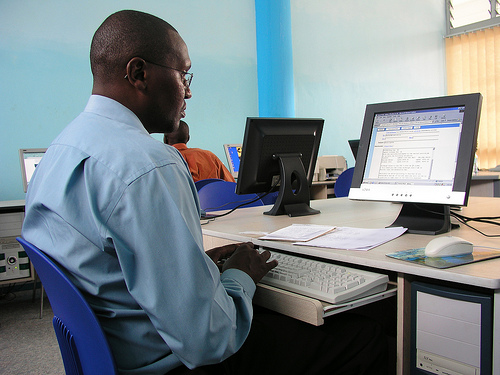<image>
Is the man on the keyboard? No. The man is not positioned on the keyboard. They may be near each other, but the man is not supported by or resting on top of the keyboard. 